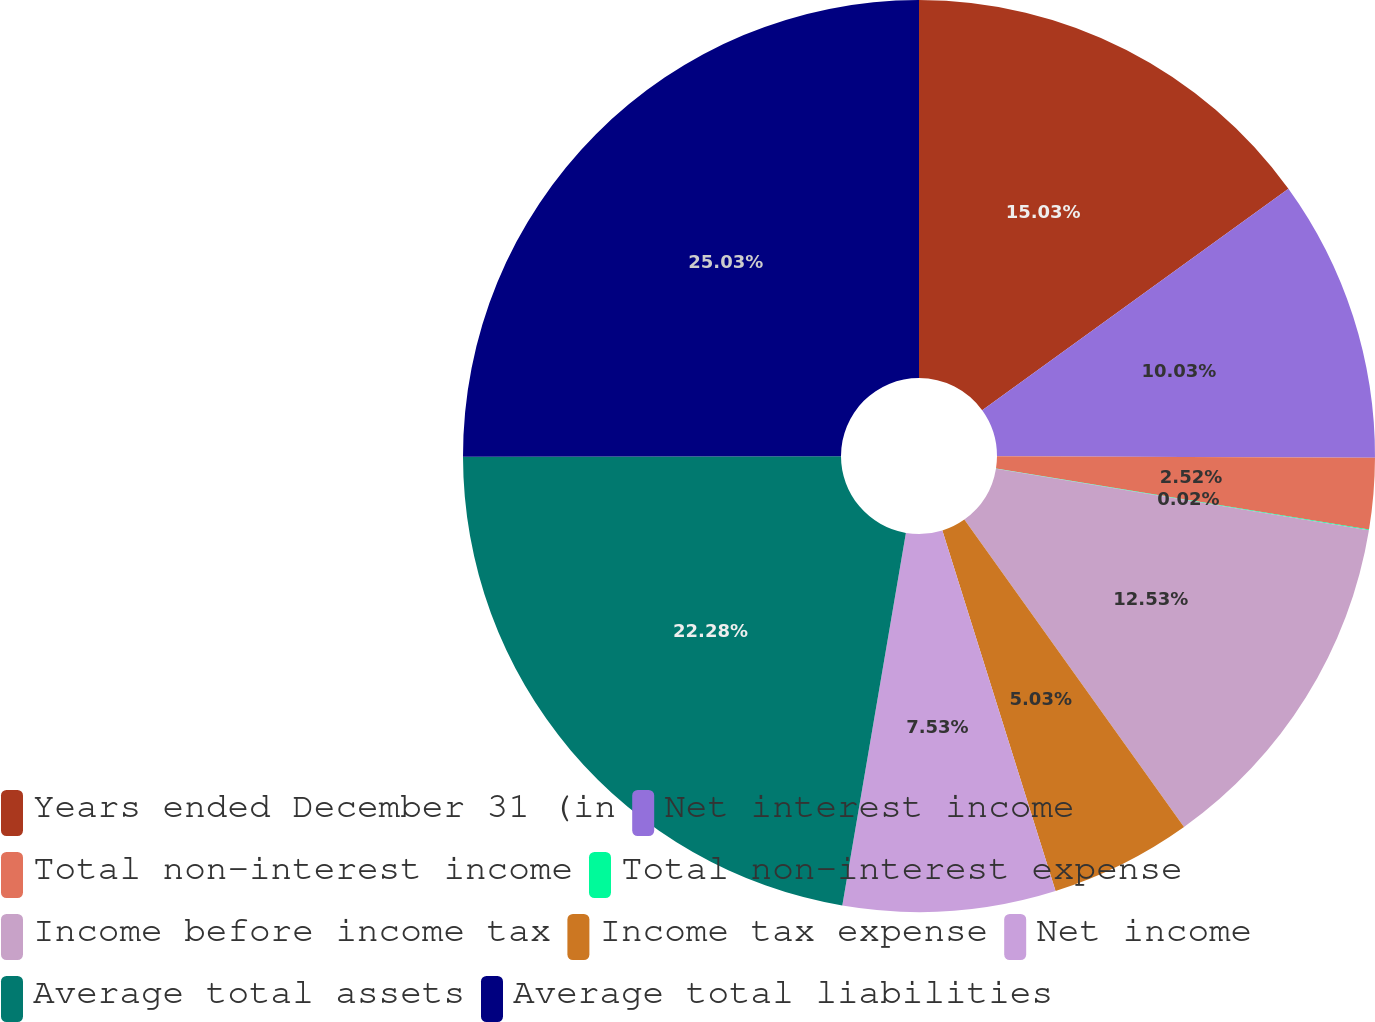Convert chart. <chart><loc_0><loc_0><loc_500><loc_500><pie_chart><fcel>Years ended December 31 (in<fcel>Net interest income<fcel>Total non-interest income<fcel>Total non-interest expense<fcel>Income before income tax<fcel>Income tax expense<fcel>Net income<fcel>Average total assets<fcel>Average total liabilities<nl><fcel>15.03%<fcel>10.03%<fcel>2.52%<fcel>0.02%<fcel>12.53%<fcel>5.03%<fcel>7.53%<fcel>22.28%<fcel>25.03%<nl></chart> 